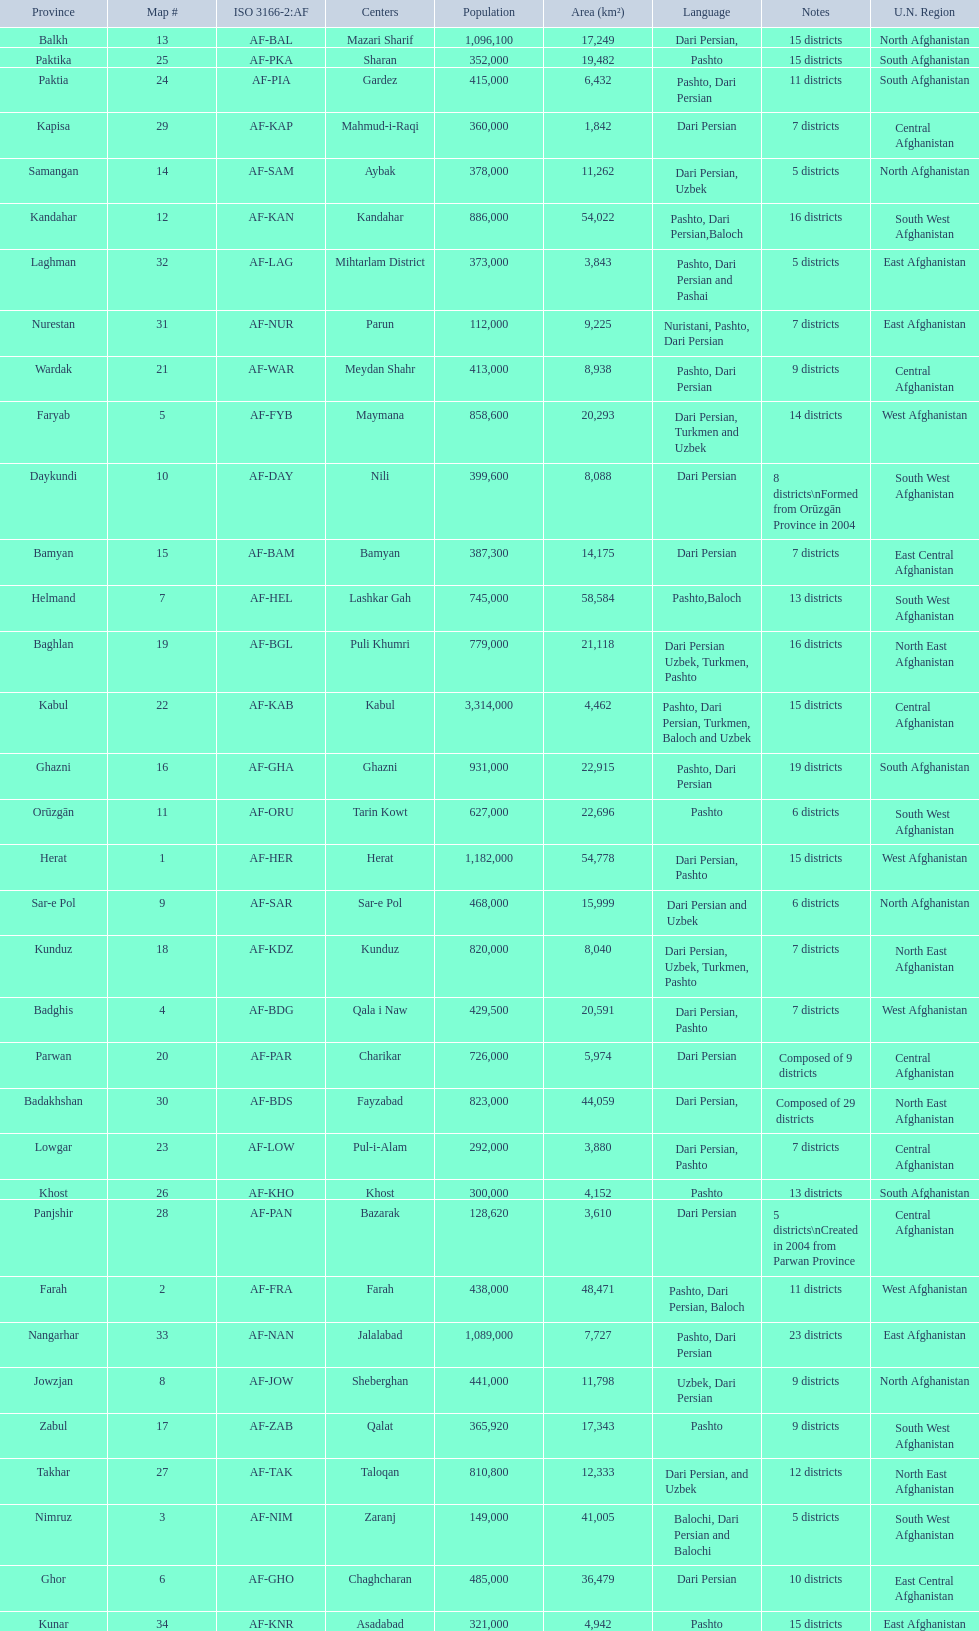How many provinces in afghanistan speak dari persian? 28. 